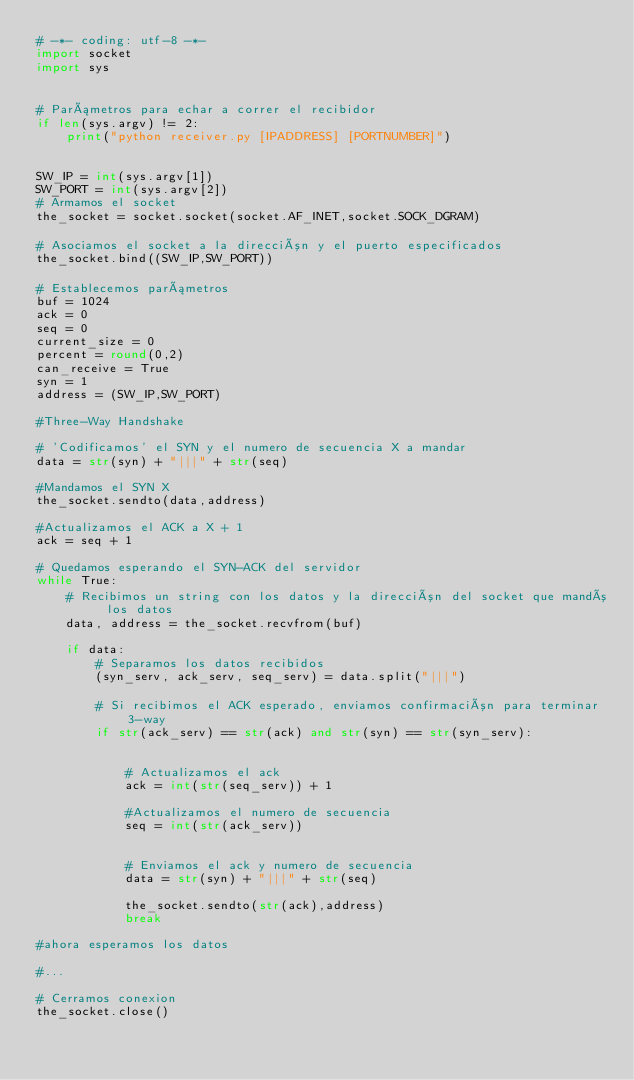<code> <loc_0><loc_0><loc_500><loc_500><_Python_># -*- coding: utf-8 -*-
import socket
import sys


# Parámetros para echar a correr el recibidor
if len(sys.argv) != 2:
    print("python receiver.py [IPADDRESS] [PORTNUMBER]")


SW_IP = int(sys.argv[1])
SW_PORT = int(sys.argv[2])
# Armamos el socket
the_socket = socket.socket(socket.AF_INET,socket.SOCK_DGRAM)

# Asociamos el socket a la dirección y el puerto especificados
the_socket.bind((SW_IP,SW_PORT))

# Establecemos parámetros
buf = 1024
ack = 0
seq = 0
current_size = 0
percent = round(0,2)
can_receive = True
syn = 1
address = (SW_IP,SW_PORT)

#Three-Way Handshake

# 'Codificamos' el SYN y el numero de secuencia X a mandar
data = str(syn) + "|||" + str(seq)

#Mandamos el SYN X
the_socket.sendto(data,address)

#Actualizamos el ACK a X + 1
ack = seq + 1

# Quedamos esperando el SYN-ACK del servidor
while True:
    # Recibimos un string con los datos y la dirección del socket que mandó los datos
    data, address = the_socket.recvfrom(buf)

    if data:
        # Separamos los datos recibidos
        (syn_serv, ack_serv, seq_serv) = data.split("|||")

        # Si recibimos el ACK esperado, enviamos confirmación para terminar 3-way
        if str(ack_serv) == str(ack) and str(syn) == str(syn_serv):


            # Actualizamos el ack
            ack = int(str(seq_serv)) + 1

            #Actualizamos el numero de secuencia
            seq = int(str(ack_serv))


            # Enviamos el ack y numero de secuencia
            data = str(syn) + "|||" + str(seq)

            the_socket.sendto(str(ack),address)
            break

#ahora esperamos los datos

#...

# Cerramos conexion
the_socket.close()

</code> 